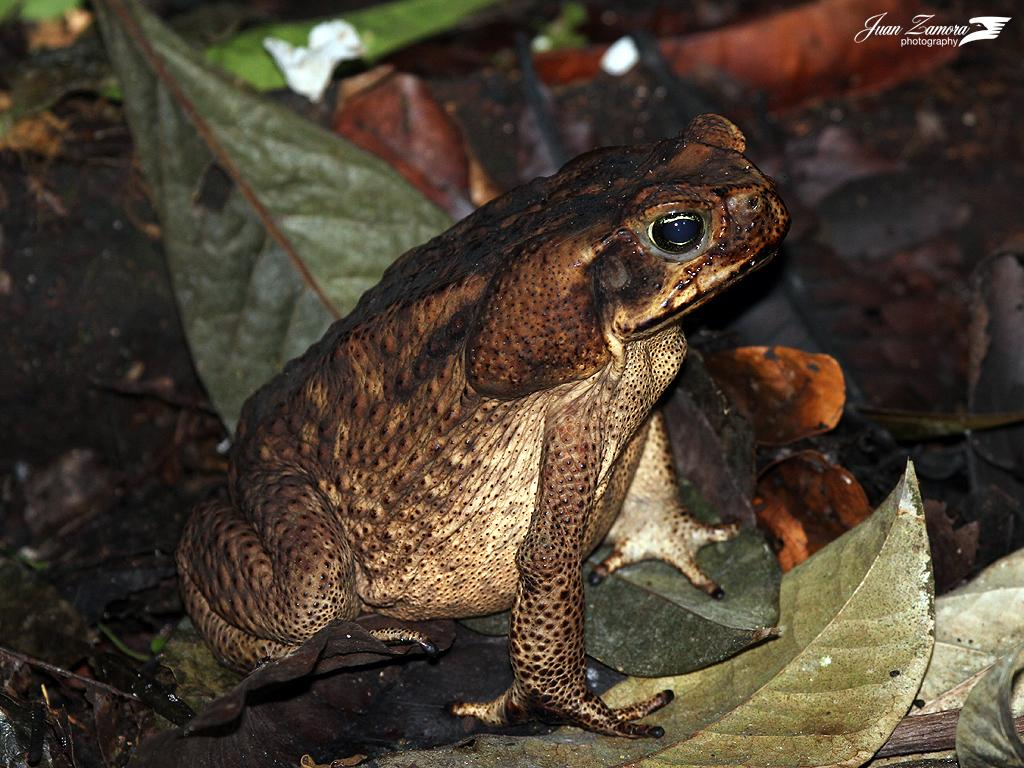What is the main subject in the foreground of the image? There is a frog in the foreground of the image. What can be seen covering the surface in the image? There are many leaves on the surface in the image. What type of surprise is the frog about to give in the image? There is no indication in the image that the frog is about to give a surprise. 